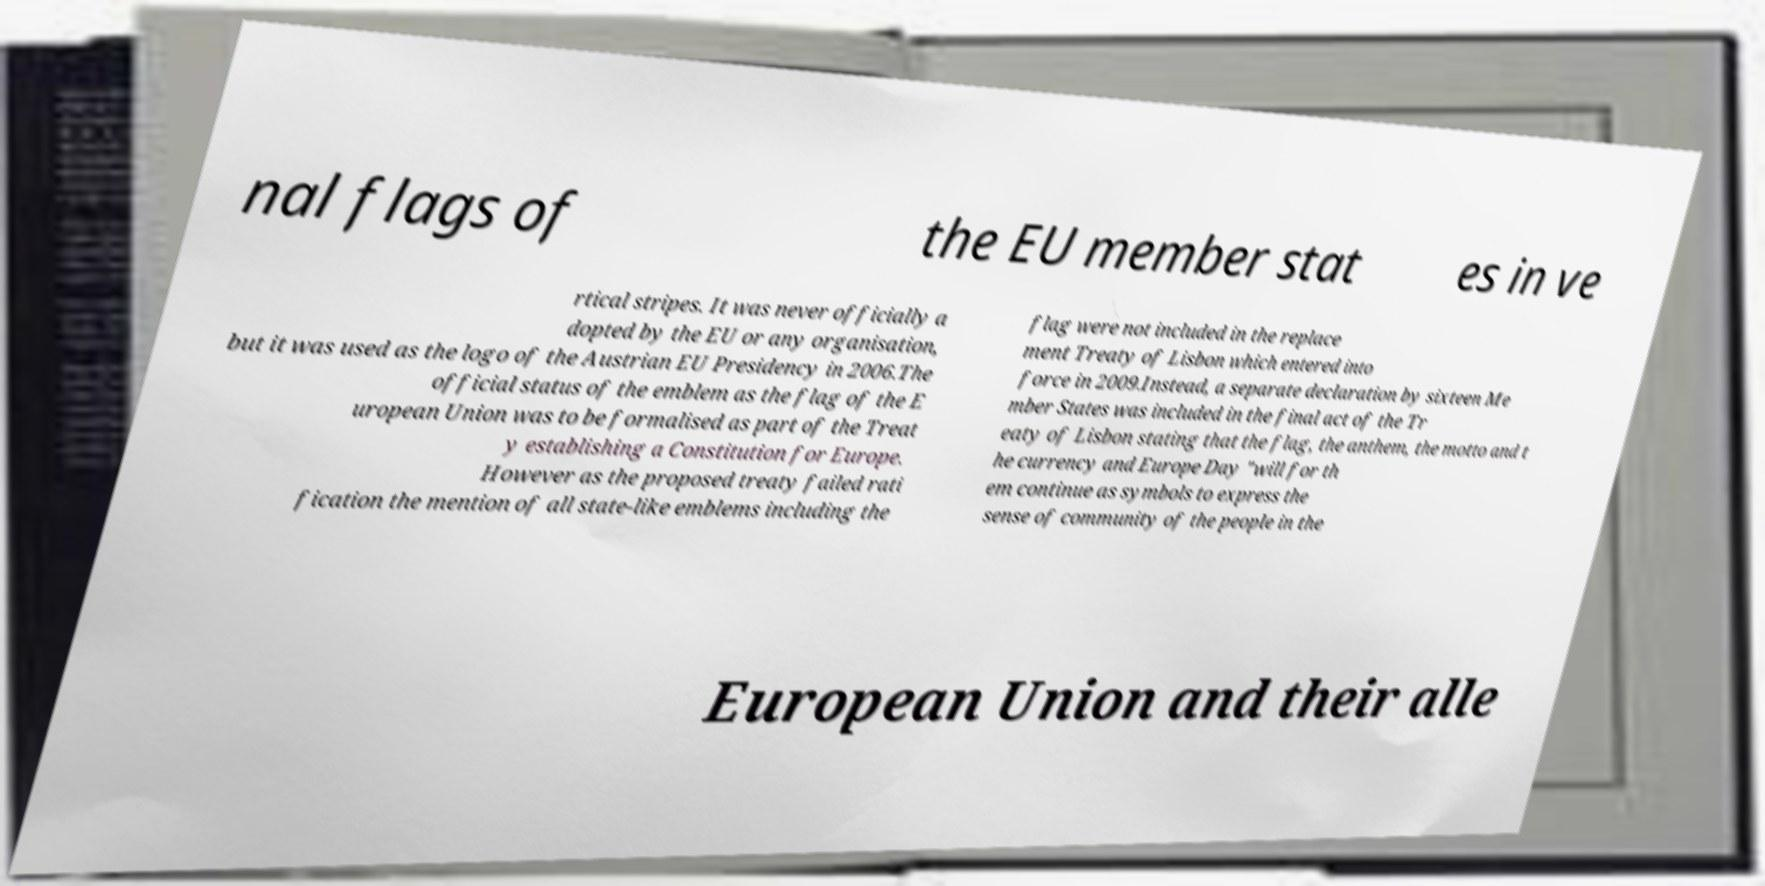Please read and relay the text visible in this image. What does it say? nal flags of the EU member stat es in ve rtical stripes. It was never officially a dopted by the EU or any organisation, but it was used as the logo of the Austrian EU Presidency in 2006.The official status of the emblem as the flag of the E uropean Union was to be formalised as part of the Treat y establishing a Constitution for Europe. However as the proposed treaty failed rati fication the mention of all state-like emblems including the flag were not included in the replace ment Treaty of Lisbon which entered into force in 2009.Instead, a separate declaration by sixteen Me mber States was included in the final act of the Tr eaty of Lisbon stating that the flag, the anthem, the motto and t he currency and Europe Day "will for th em continue as symbols to express the sense of community of the people in the European Union and their alle 